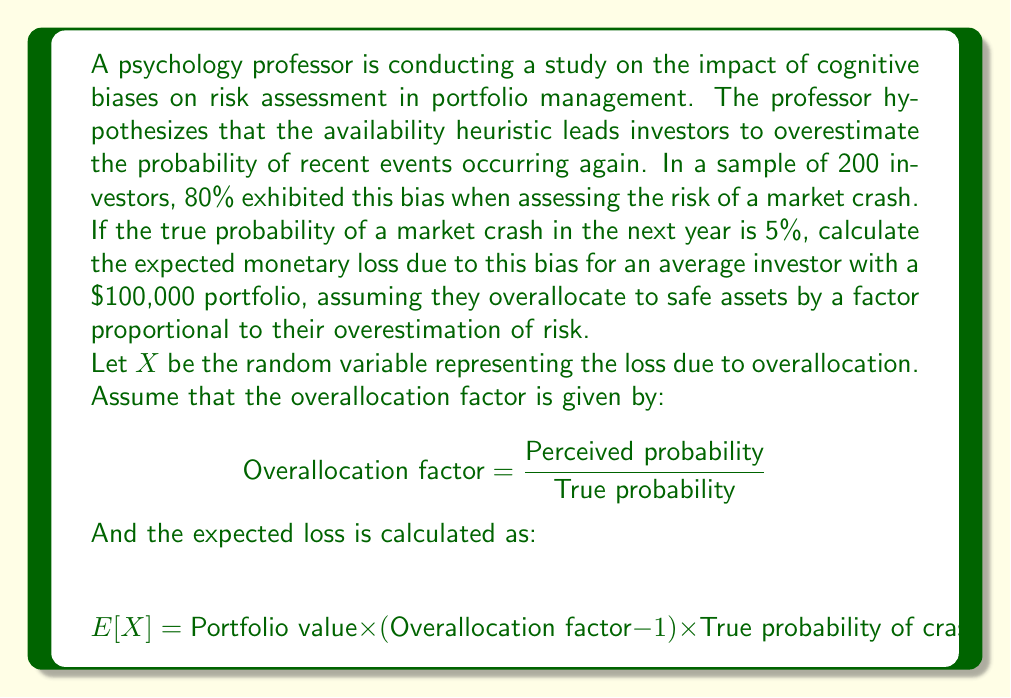Could you help me with this problem? To solve this problem, we need to follow these steps:

1. Calculate the perceived probability of a market crash:
   The availability heuristic leads 80% of investors to overestimate the probability. Let's assume they perceive the probability as the likelihood of the most recent major crash. For example, if the last major crash was 10 years ago, they might perceive the annual probability as 1/10 = 10%.

2. Calculate the overallocation factor:
   $$ \text{Overallocation factor} = \frac{\text{Perceived probability}}{\text{True probability}} = \frac{10\%}{5\%} = 2 $$

3. Calculate the expected loss using the given formula:
   $$ E[X] = \text{Portfolio value} \times (\text{Overallocation factor} - 1) \times \text{True probability of crash} $$
   $$ E[X] = \$100,000 \times (2 - 1) \times 0.05 $$
   $$ E[X] = \$100,000 \times 1 \times 0.05 $$
   $$ E[X] = \$5,000 $$

This result suggests that, on average, an investor with a $100,000 portfolio who exhibits this cognitive bias would be expected to lose $5,000 due to overallocation to safe assets based on their overestimation of the risk of a market crash.
Answer: The expected monetary loss due to the availability heuristic bias for an average investor with a $100,000 portfolio is $5,000. 